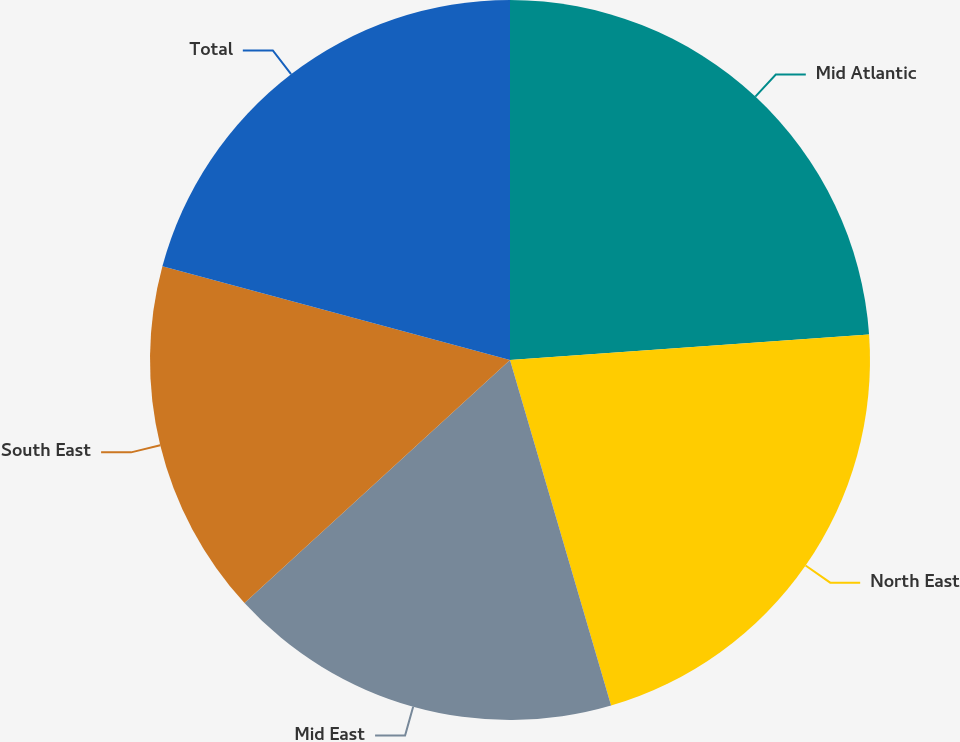Convert chart to OTSL. <chart><loc_0><loc_0><loc_500><loc_500><pie_chart><fcel>Mid Atlantic<fcel>North East<fcel>Mid East<fcel>South East<fcel>Total<nl><fcel>23.87%<fcel>21.6%<fcel>17.73%<fcel>15.99%<fcel>20.81%<nl></chart> 